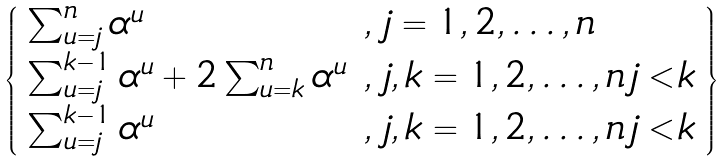<formula> <loc_0><loc_0><loc_500><loc_500>\left \{ \begin{array} { l l } \sum _ { u = j } ^ { n } \alpha ^ { u } & , \, j = 1 , 2 , \dots , n \\ \sum _ { u = j } ^ { k - 1 } \alpha ^ { u } + 2 \sum _ { u = k } ^ { n } \alpha ^ { u } & , \, j , k = 1 , 2 , \dots , n \, j < k \\ \sum _ { u = j } ^ { k - 1 } \alpha ^ { u } & , \, j , k = 1 , 2 , \dots , n \, j < k \end{array} \right \}</formula> 